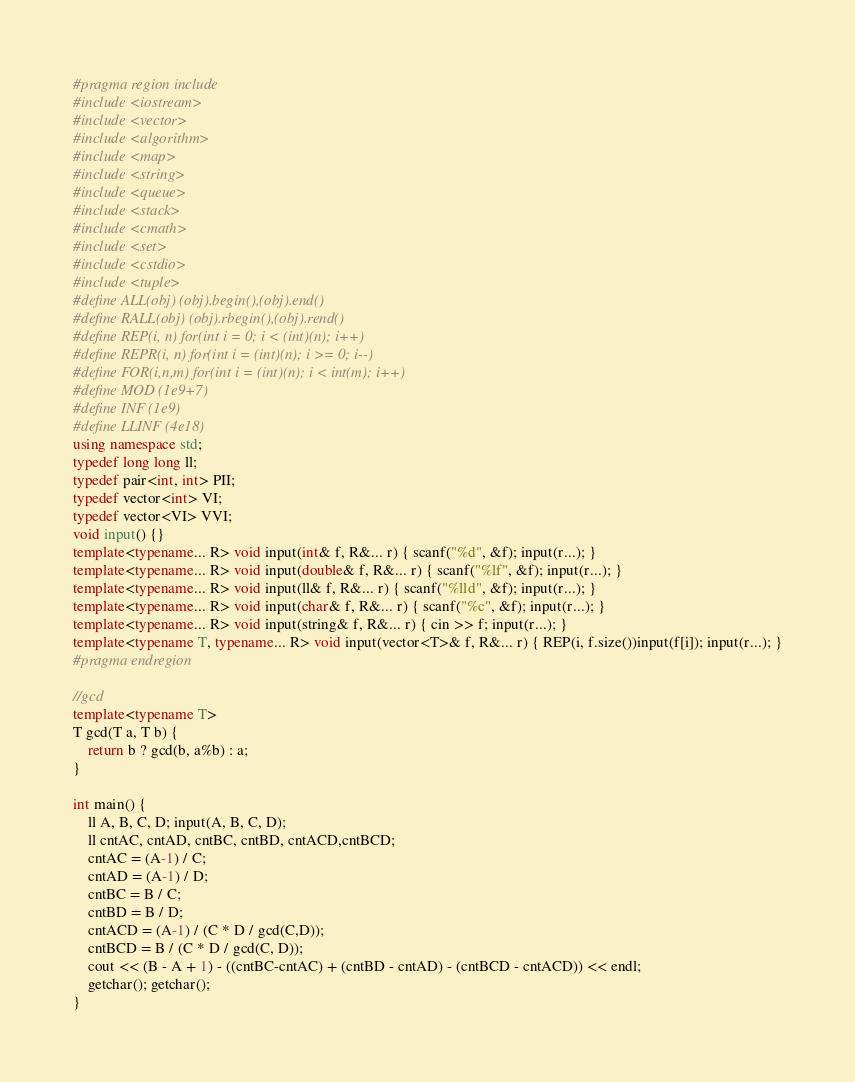<code> <loc_0><loc_0><loc_500><loc_500><_C++_>#pragma region include
#include <iostream>
#include <vector>
#include <algorithm>
#include <map>
#include <string>
#include <queue>
#include <stack>
#include <cmath>
#include <set>
#include <cstdio>
#include <tuple>
#define ALL(obj) (obj).begin(),(obj).end()
#define RALL(obj) (obj).rbegin(),(obj).rend()
#define REP(i, n) for(int i = 0; i < (int)(n); i++)
#define REPR(i, n) for(int i = (int)(n); i >= 0; i--)
#define FOR(i,n,m) for(int i = (int)(n); i < int(m); i++)
#define MOD (1e9+7)
#define INF (1e9)
#define LLINF (4e18)
using namespace std;
typedef long long ll;
typedef pair<int, int> PII;
typedef vector<int> VI;
typedef vector<VI> VVI;
void input() {}
template<typename... R> void input(int& f, R&... r) { scanf("%d", &f); input(r...); }
template<typename... R> void input(double& f, R&... r) { scanf("%lf", &f); input(r...); }
template<typename... R> void input(ll& f, R&... r) { scanf("%lld", &f); input(r...); }
template<typename... R> void input(char& f, R&... r) { scanf("%c", &f); input(r...); }
template<typename... R> void input(string& f, R&... r) { cin >> f; input(r...); }
template<typename T, typename... R> void input(vector<T>& f, R&... r) { REP(i, f.size())input(f[i]); input(r...); }
#pragma endregion

//gcd
template<typename T>
T gcd(T a, T b) {
    return b ? gcd(b, a%b) : a;
}

int main() {
    ll A, B, C, D; input(A, B, C, D);
    ll cntAC, cntAD, cntBC, cntBD, cntACD,cntBCD;
    cntAC = (A-1) / C;
    cntAD = (A-1) / D;
    cntBC = B / C;
    cntBD = B / D;
    cntACD = (A-1) / (C * D / gcd(C,D));
    cntBCD = B / (C * D / gcd(C, D));
    cout << (B - A + 1) - ((cntBC-cntAC) + (cntBD - cntAD) - (cntBCD - cntACD)) << endl;
    getchar(); getchar();
}</code> 